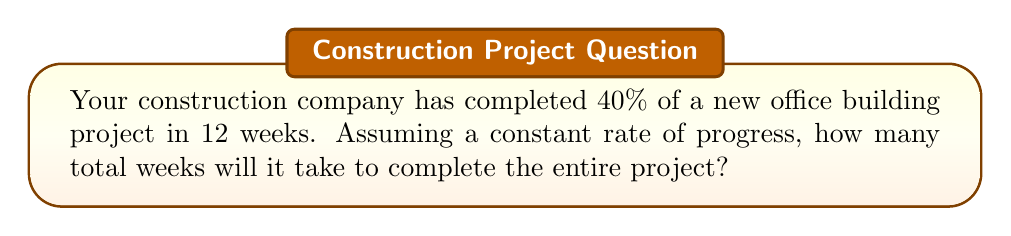Provide a solution to this math problem. Let's approach this step-by-step:

1) First, we need to set up the relationship between the progress and time:
   
   $\frac{\text{Progress}}{\text{Time}} = \text{Constant Rate}$

2) We know that 40% of the project was completed in 12 weeks. Let's express this mathematically:

   $\frac{40\%}{12 \text{ weeks}} = \text{Constant Rate}$

3) We can simplify this fraction:

   $\frac{40}{120} = \frac{1}{3} \text{ per week}$

4) This means that 1/3 of the project is completed each week.

5) To find the total time for the entire project, we set up this equation:

   $\frac{100\%}{x \text{ weeks}} = \frac{1}{3} \text{ per week}$

6) Cross multiply:

   $100 = \frac{x}{3}$

7) Solve for x:

   $x = 100 * 3 = 300$

8) Therefore, it will take 30 weeks to complete the entire project.

This can be verified:
$\frac{40\%}{12 \text{ weeks}} = \frac{100\%}{30 \text{ weeks}} = \frac{10}{3}\% \text{ per week}$
Answer: 30 weeks 